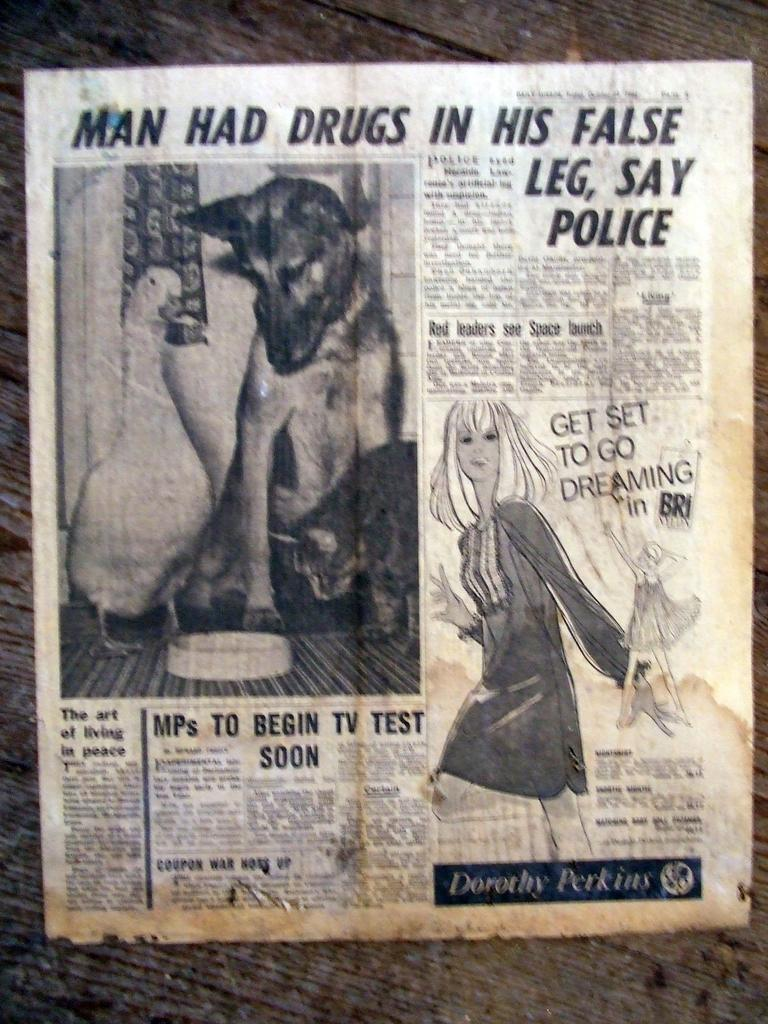What is the main object in the center of the image? There is a paper in the center of the image. What can be found on the paper? The paper contains text. Who or what else is present in the image? There is a person and a dog in the image. What can be seen in the background of the image? There is a wall in the background of the image. How many tickets can be seen in the image? There are no tickets present in the image. What type of bikes are visible in the image? There are no bikes present in the image. 